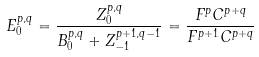<formula> <loc_0><loc_0><loc_500><loc_500>E _ { 0 } ^ { p , q } = { \frac { Z _ { 0 } ^ { p , q } } { B _ { 0 } ^ { p , q } + Z _ { - 1 } ^ { p + 1 , q - 1 } } } = { \frac { F ^ { p } C ^ { p + q } } { F ^ { p + 1 } C ^ { p + q } } }</formula> 